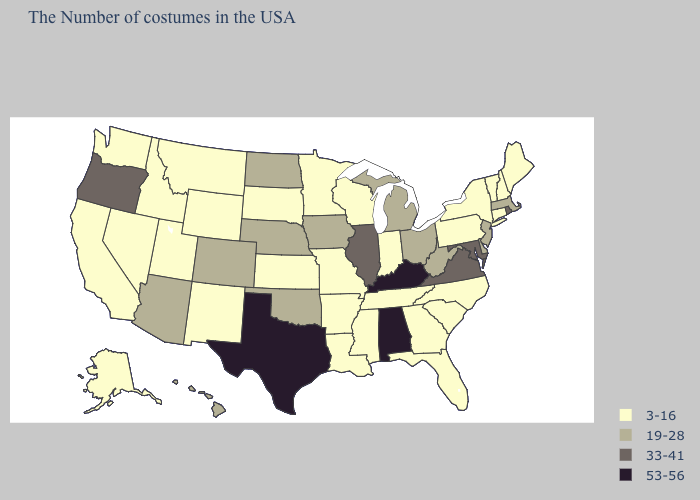Does Oregon have the lowest value in the West?
Write a very short answer. No. Which states have the lowest value in the MidWest?
Keep it brief. Indiana, Wisconsin, Missouri, Minnesota, Kansas, South Dakota. Name the states that have a value in the range 33-41?
Write a very short answer. Rhode Island, Maryland, Virginia, Illinois, Oregon. Among the states that border Virginia , which have the highest value?
Keep it brief. Kentucky. Name the states that have a value in the range 19-28?
Concise answer only. Massachusetts, New Jersey, Delaware, West Virginia, Ohio, Michigan, Iowa, Nebraska, Oklahoma, North Dakota, Colorado, Arizona, Hawaii. What is the lowest value in the USA?
Short answer required. 3-16. Does the first symbol in the legend represent the smallest category?
Quick response, please. Yes. Among the states that border California , does Nevada have the lowest value?
Write a very short answer. Yes. Which states have the highest value in the USA?
Concise answer only. Kentucky, Alabama, Texas. Among the states that border Nebraska , does Iowa have the lowest value?
Keep it brief. No. Does Rhode Island have the highest value in the Northeast?
Write a very short answer. Yes. Does Oregon have the same value as Alabama?
Be succinct. No. Does the first symbol in the legend represent the smallest category?
Write a very short answer. Yes. Name the states that have a value in the range 3-16?
Quick response, please. Maine, New Hampshire, Vermont, Connecticut, New York, Pennsylvania, North Carolina, South Carolina, Florida, Georgia, Indiana, Tennessee, Wisconsin, Mississippi, Louisiana, Missouri, Arkansas, Minnesota, Kansas, South Dakota, Wyoming, New Mexico, Utah, Montana, Idaho, Nevada, California, Washington, Alaska. Name the states that have a value in the range 19-28?
Concise answer only. Massachusetts, New Jersey, Delaware, West Virginia, Ohio, Michigan, Iowa, Nebraska, Oklahoma, North Dakota, Colorado, Arizona, Hawaii. 